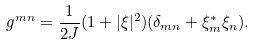Convert formula to latex. <formula><loc_0><loc_0><loc_500><loc_500>g ^ { m n } = \frac { 1 } { 2 J } ( 1 + | \xi | ^ { 2 } ) ( \delta _ { m n } + \xi ^ { * } _ { m } \xi _ { n } ) .</formula> 